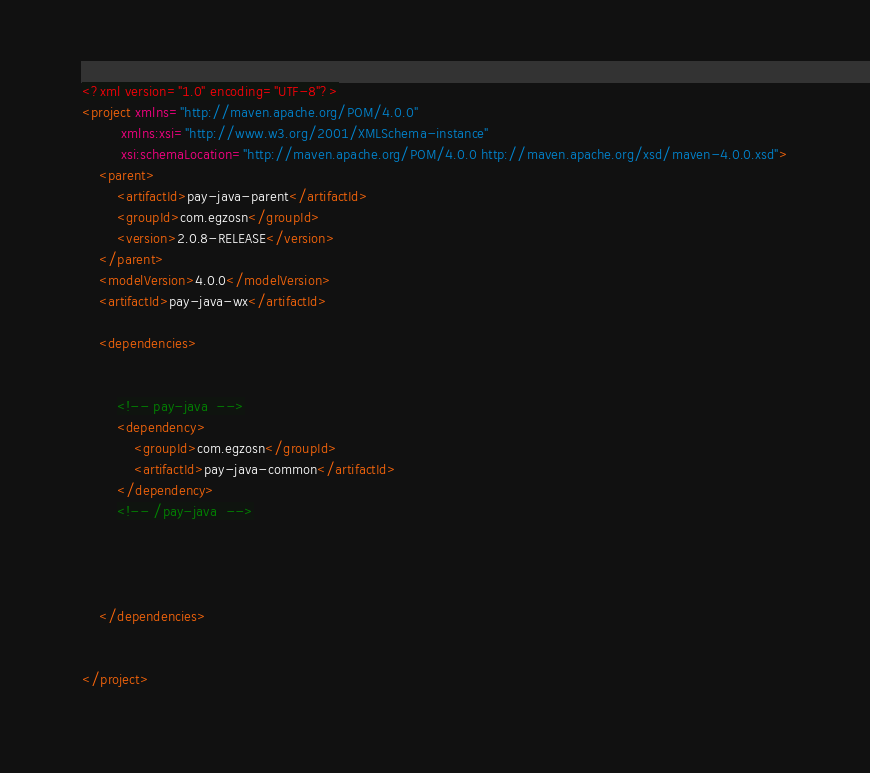<code> <loc_0><loc_0><loc_500><loc_500><_XML_><?xml version="1.0" encoding="UTF-8"?>
<project xmlns="http://maven.apache.org/POM/4.0.0"
         xmlns:xsi="http://www.w3.org/2001/XMLSchema-instance"
         xsi:schemaLocation="http://maven.apache.org/POM/4.0.0 http://maven.apache.org/xsd/maven-4.0.0.xsd">
    <parent>
        <artifactId>pay-java-parent</artifactId>
        <groupId>com.egzosn</groupId>
        <version>2.0.8-RELEASE</version>
    </parent>
    <modelVersion>4.0.0</modelVersion>
    <artifactId>pay-java-wx</artifactId>

    <dependencies>


        <!-- pay-java  -->
        <dependency>
            <groupId>com.egzosn</groupId>
            <artifactId>pay-java-common</artifactId>
        </dependency>
        <!-- /pay-java  -->




    </dependencies>


</project></code> 